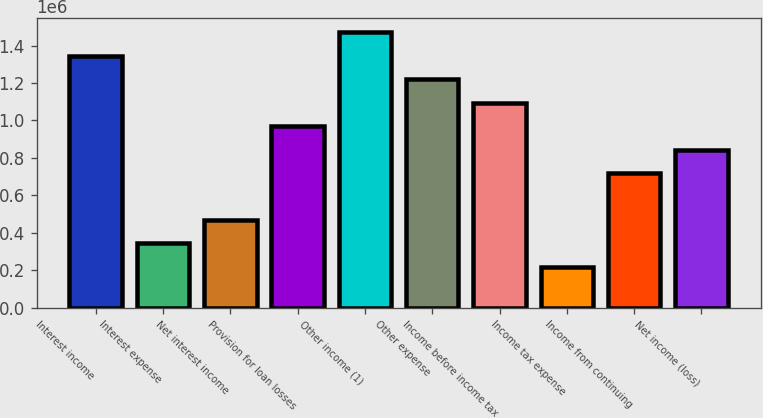Convert chart to OTSL. <chart><loc_0><loc_0><loc_500><loc_500><bar_chart><fcel>Interest income<fcel>Interest expense<fcel>Net interest income<fcel>Provision for loan losses<fcel>Other income (1)<fcel>Other expense<fcel>Income before income tax<fcel>Income tax expense<fcel>Income from continuing<fcel>Net income (loss)<nl><fcel>1.34592e+06<fcel>343075<fcel>468431<fcel>969854<fcel>1.47128e+06<fcel>1.22057e+06<fcel>1.09521e+06<fcel>217719<fcel>719142<fcel>844498<nl></chart> 